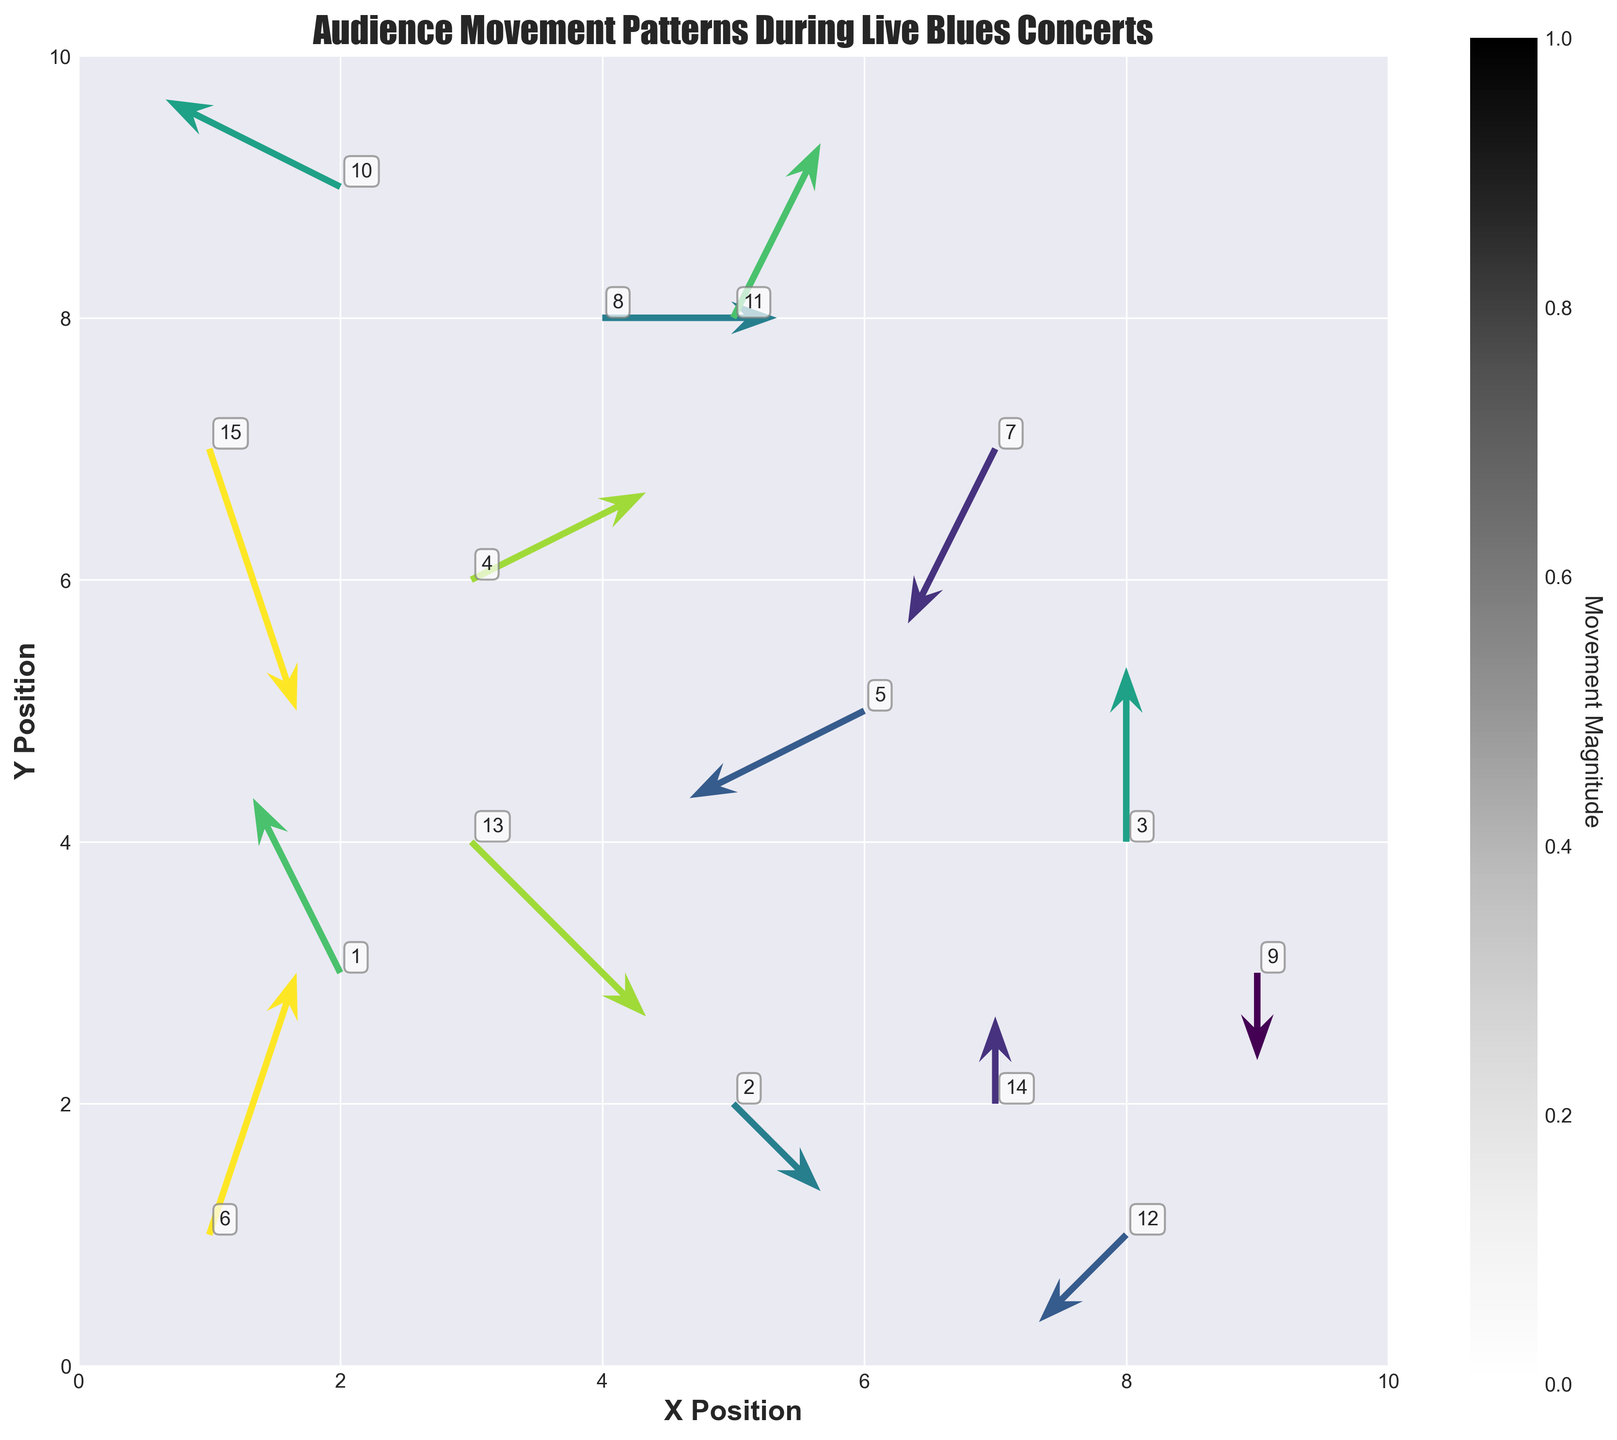What's the title of the plot? The title is typically found at the top of the plot and reads as described in the problem.
Answer: Audience Movement Patterns During Live Blues Concerts What are the labels for the X and Y axes? Axis labels are generally found along the respective axes and provide the measurement units or description used. They are specified in the problem.
Answer: X Position (X) and Y Position (Y) How many arrows (data points) are displayed on the plot? To count the number of data points, observe each arrow represented in the quiver plot. Total data points specified.
Answer: 15 What is the direction of movement at position (2, 3)? Find the coordinates and trace the direction/arrow originating from this point.
Answer: Upwards and to the left Which point has the highest movement magnitude? Check the colors representing magnitude or use the annotations. Compare each value visually noted in the plot or listed data.
Answer: Point at (1, 1) and (1, 7) At which positions are the arrows moving directly downward? Identify arrows with direction vectors that only have a negative Y component and 0 X component.
Answer: Positions (5, 2), (9, 3), and (1, 7) What is the average magnitude of movement? Add all the magnitudes together and divide by the total number of data points to find the mean value.
Answer: 0.7 Which data points indicate movement to the right? Check arrows that have a positive X component.
Answer: Points at (3, 6), (4, 8), (3, 4), (1, 1), and (5, 8) Are there any zero-movement data points, and if so, where are they located? Check if any arrow has zero magnitude visually or by confirming the data.
Answer: None 